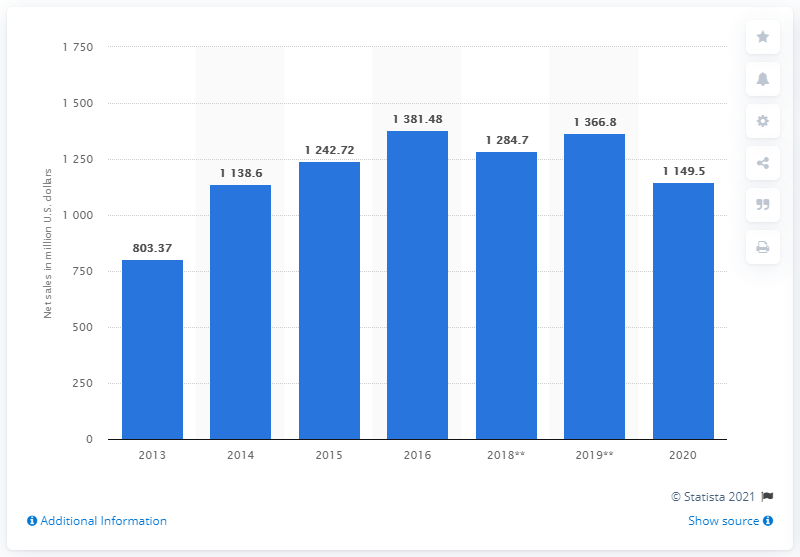Give some essential details in this illustration. Net sales for Kate Spade in FY2020 were 1,149.5 million US dollars. 